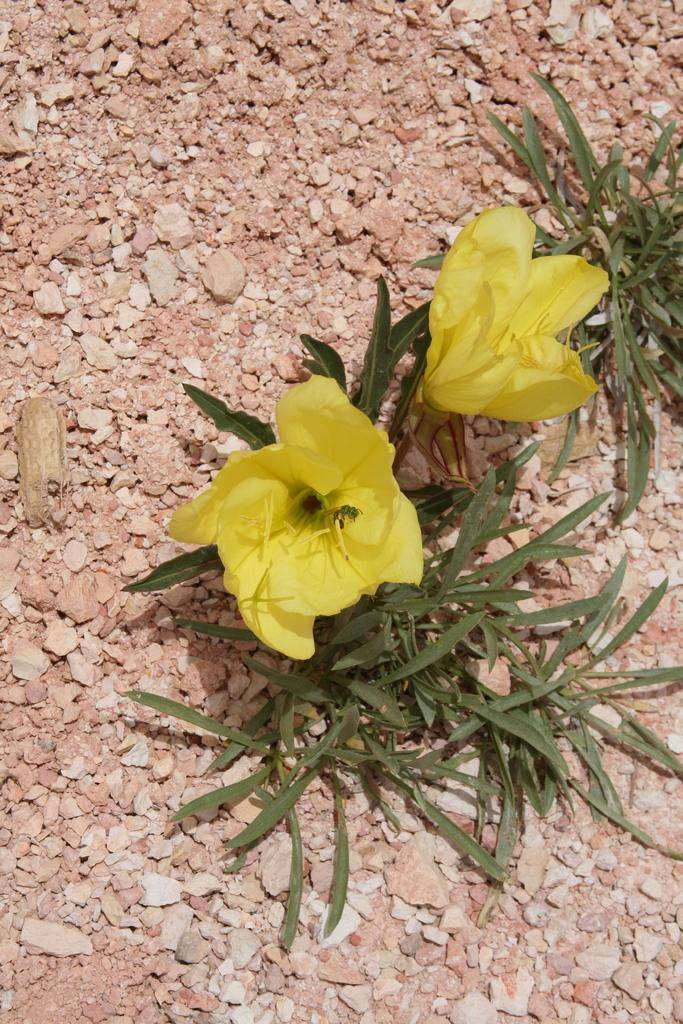What type of flowers can be seen in the image? There are yellow color flowers in the image. What else is present in the image besides the flowers? There are leaves in the image. On what surface are the flowers and leaves situated? The flowers and leaves are on a stones texture. How many wheels can be seen in the image? There are no wheels present in the image. Is there a deer visible in the image? There is no deer present in the image. 